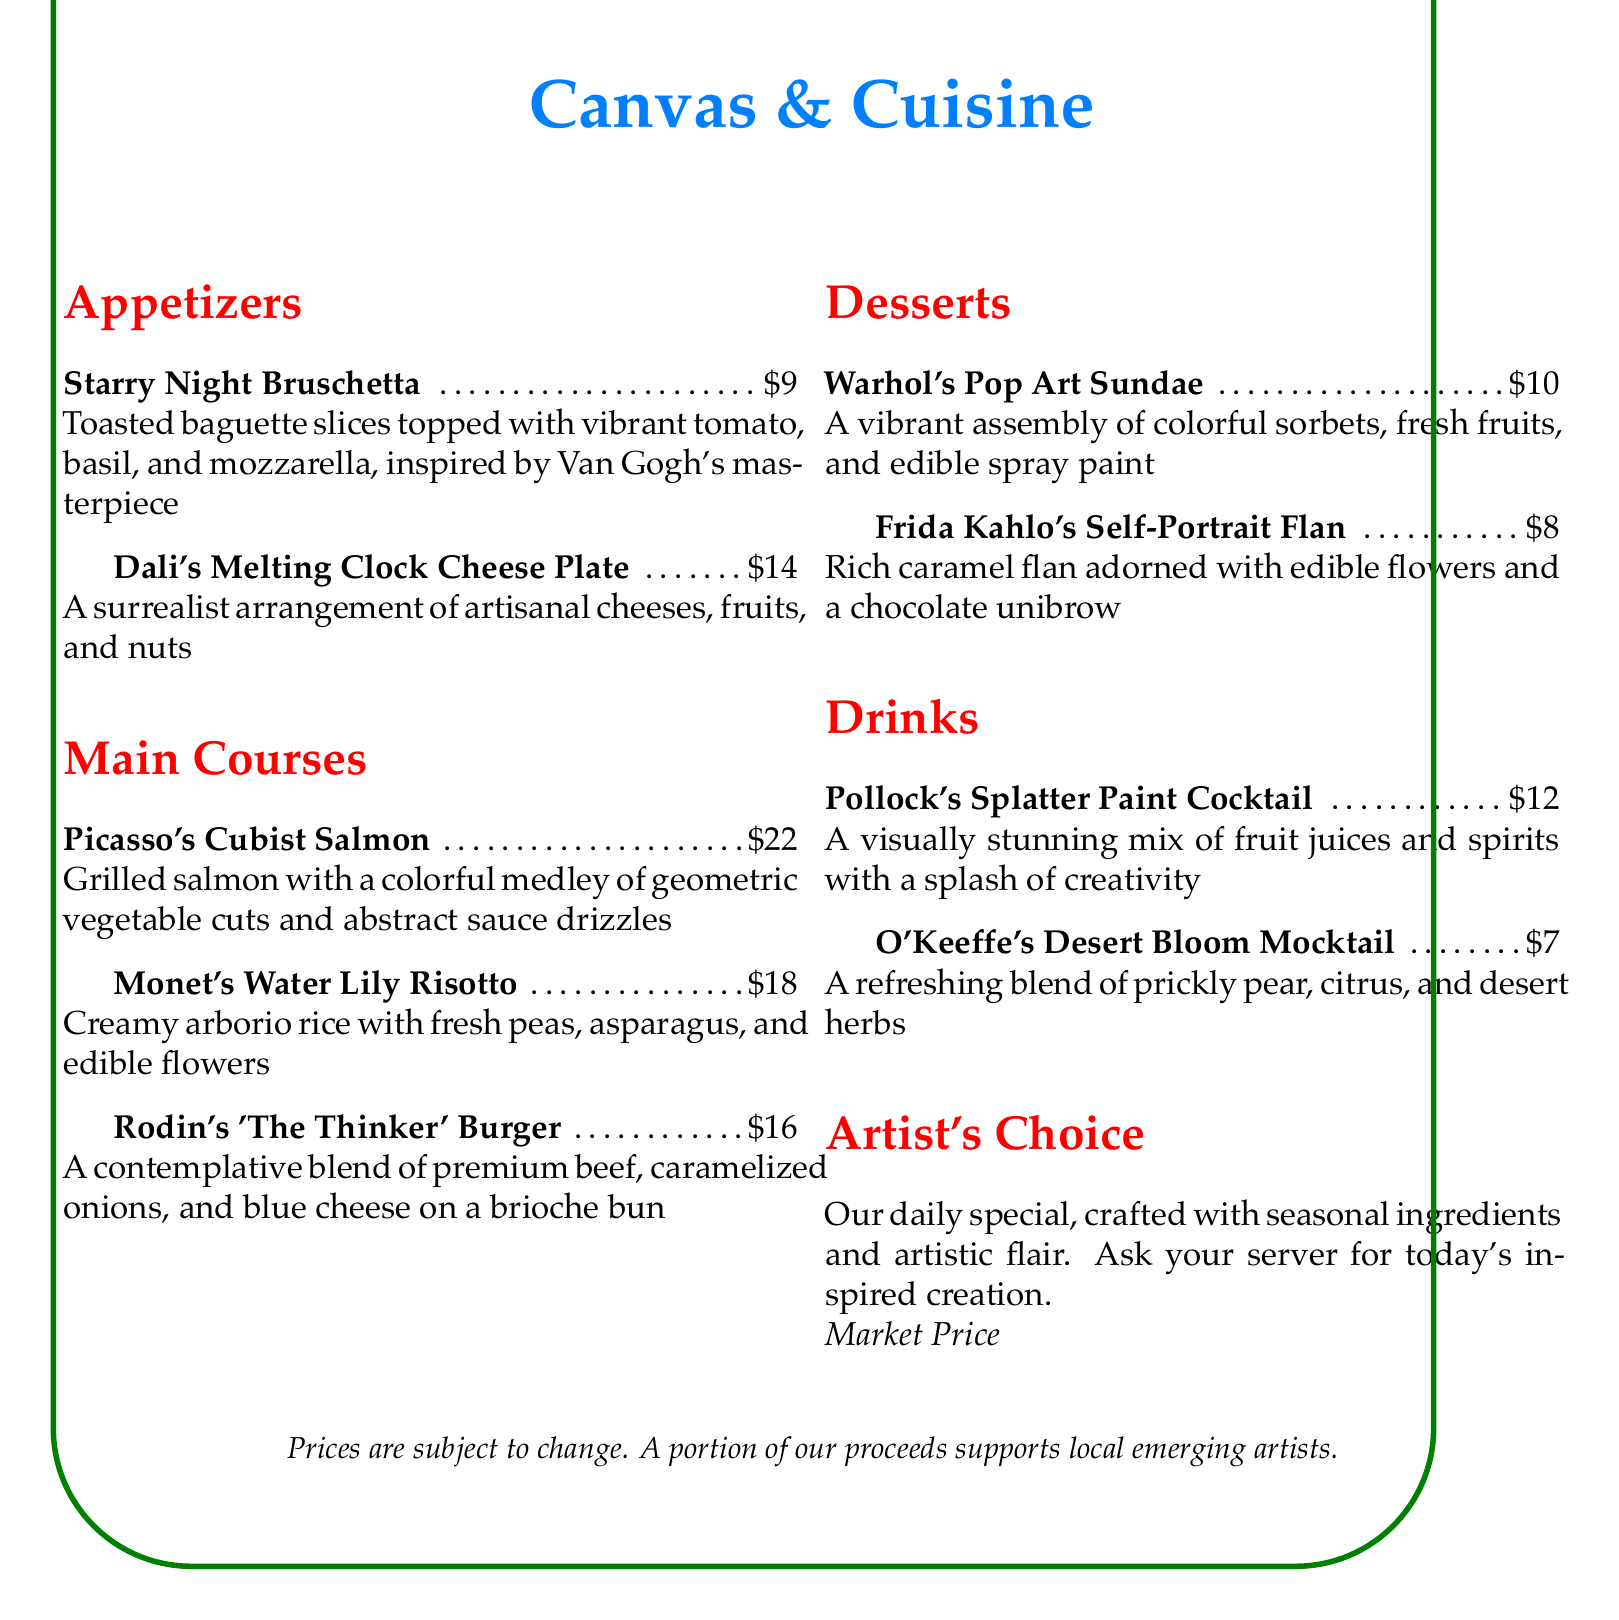What is the name of the appetizer inspired by Van Gogh? The appetizer inspired by Van Gogh is specifically named "Starry Night Bruschetta."
Answer: Starry Night Bruschetta What is the price of Monet's Water Lily Risotto? The price listed for Monet's Water Lily Risotto is $18.
Answer: $18 What type of cheese is featured in Dali's Melting Clock Cheese Plate? Dali's Melting Clock Cheese Plate includes an arrangement of artisanal cheeses.
Answer: Artisanal cheeses How much does Frida Kahlo's Self-Portrait Flan cost? The document indicates that Frida Kahlo's Self-Portrait Flan costs $8.
Answer: $8 What is the price range for the Artist's Choice special? The price for Artist's Choice is indicated as a market price, meaning it can vary daily.
Answer: Market Price How many main courses are featured on the menu? The menu lists three distinct main courses as part of its offerings.
Answer: Three What type of mocktail is offered in the drink section? The mocktail offered in the drink section is named "O'Keeffe's Desert Bloom Mocktail."
Answer: O'Keeffe's Desert Bloom Mocktail Which artist inspired the dessert called Warhol's Pop Art Sundae? The dessert called Warhol's Pop Art Sundae is inspired by the artist Andy Warhol.
Answer: Andy Warhol 